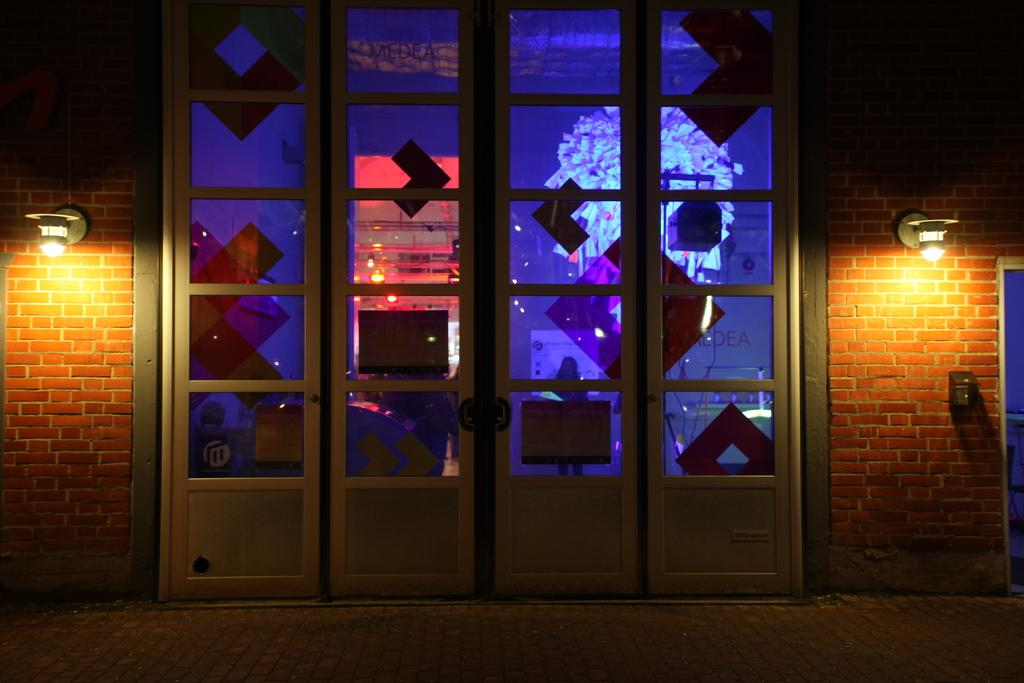What type of doors are present in the image? There are glass doors in the image. What can be seen illuminating the area in the image? There are lights visible in the image. What type of wall is present in the image? There is a brick wall in the image. How many snails can be seen crawling on the brick wall in the image? There are no snails present in the image; it only features glass doors, lights, and a brick wall. What is the mass of the wristwatch visible on the glass doors in the image? There is no wristwatch present in the image, so it is not possible to determine its mass. 